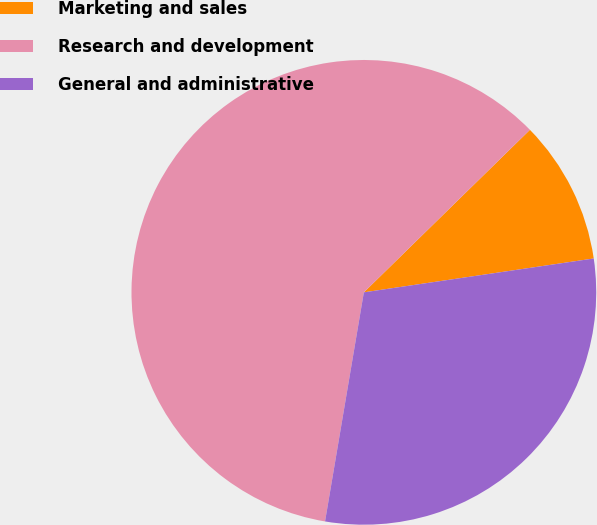Convert chart to OTSL. <chart><loc_0><loc_0><loc_500><loc_500><pie_chart><fcel>Marketing and sales<fcel>Research and development<fcel>General and administrative<nl><fcel>10.0%<fcel>60.0%<fcel>30.0%<nl></chart> 